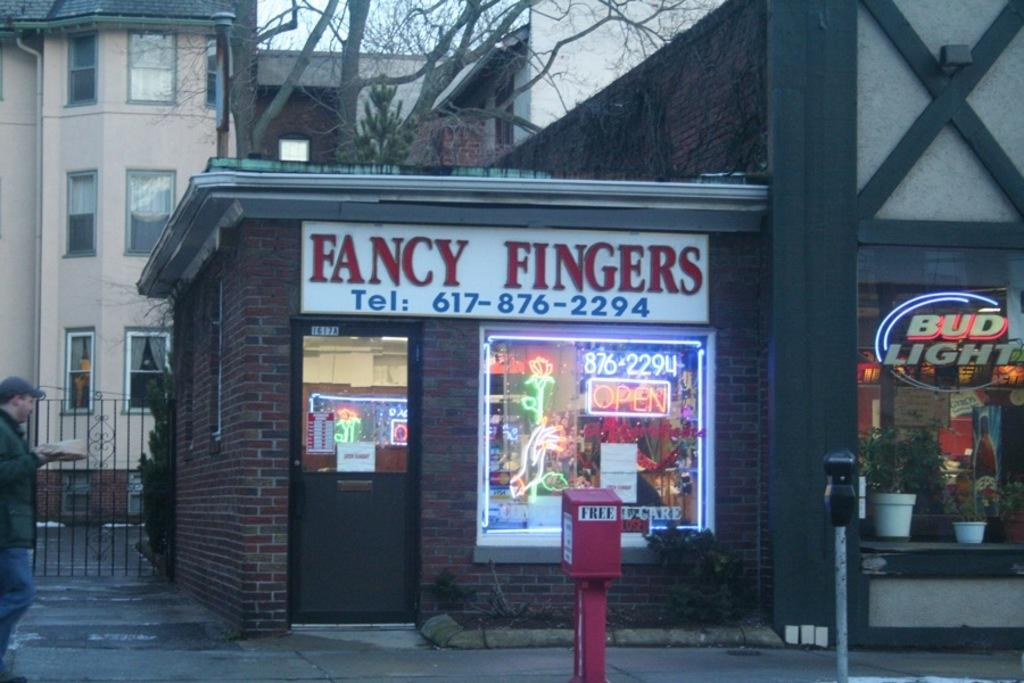<image>
Offer a succinct explanation of the picture presented. A small shop called Fancy Fingers that is attached to a larger shop. 